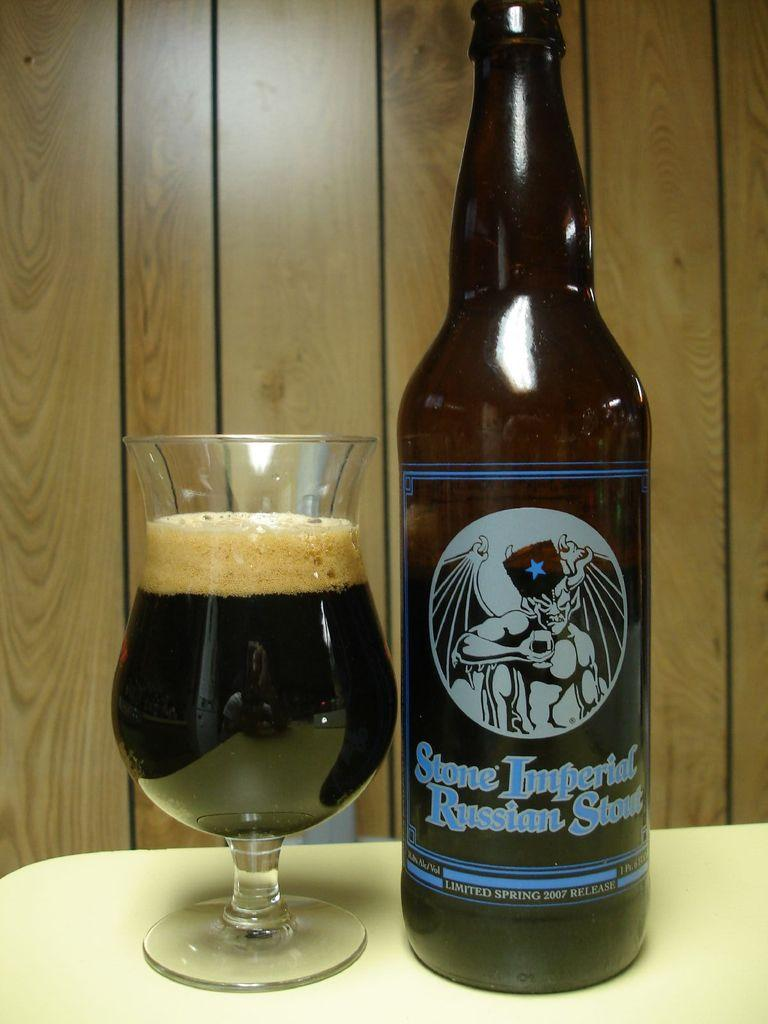<image>
Relay a brief, clear account of the picture shown. a bottle of stone imperial russion stout next to a glass of it on a counter 